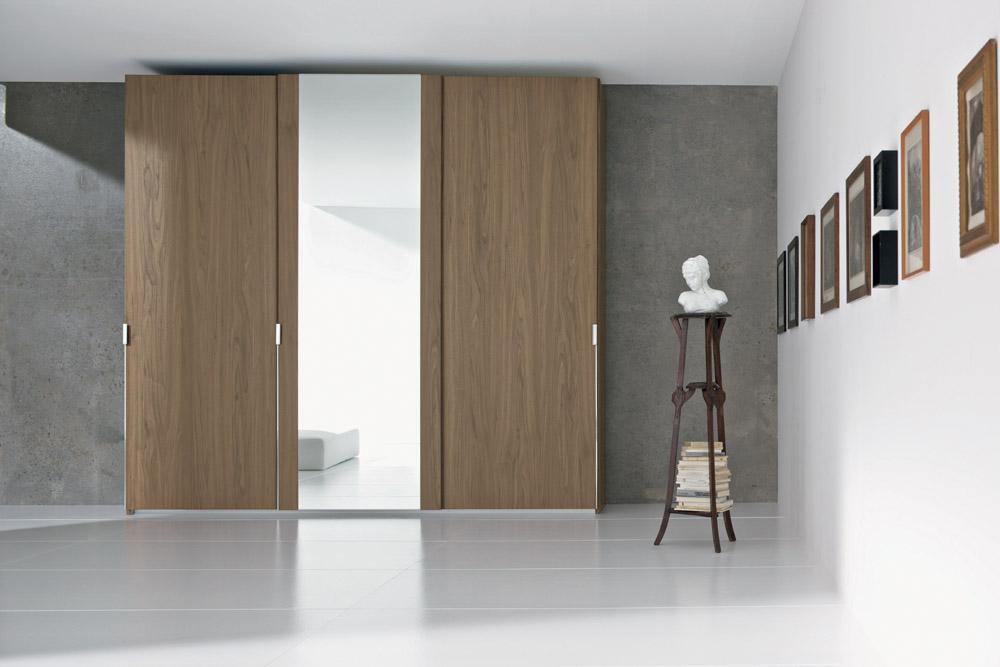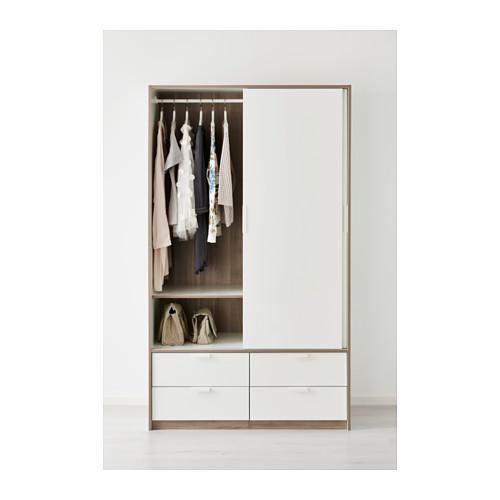The first image is the image on the left, the second image is the image on the right. Examine the images to the left and right. Is the description "Clothing is hanging in the wardrobe in the image on the right." accurate? Answer yes or no. Yes. The first image is the image on the left, the second image is the image on the right. For the images shown, is this caption "One image shows a single white wardrobe, with an open area where clothes hang on the left." true? Answer yes or no. Yes. 